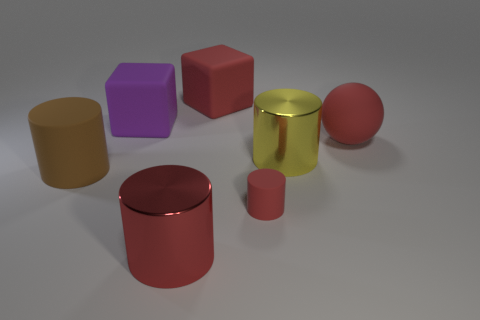Add 2 red things. How many objects exist? 9 Subtract all large yellow metallic cylinders. How many cylinders are left? 3 Subtract all yellow cylinders. How many cylinders are left? 3 Subtract 2 cylinders. How many cylinders are left? 2 Subtract all cylinders. How many objects are left? 3 Subtract all purple spheres. Subtract all cyan cubes. How many spheres are left? 1 Subtract all small metallic objects. Subtract all purple matte cubes. How many objects are left? 6 Add 2 large red spheres. How many large red spheres are left? 3 Add 6 purple matte cubes. How many purple matte cubes exist? 7 Subtract 0 purple spheres. How many objects are left? 7 